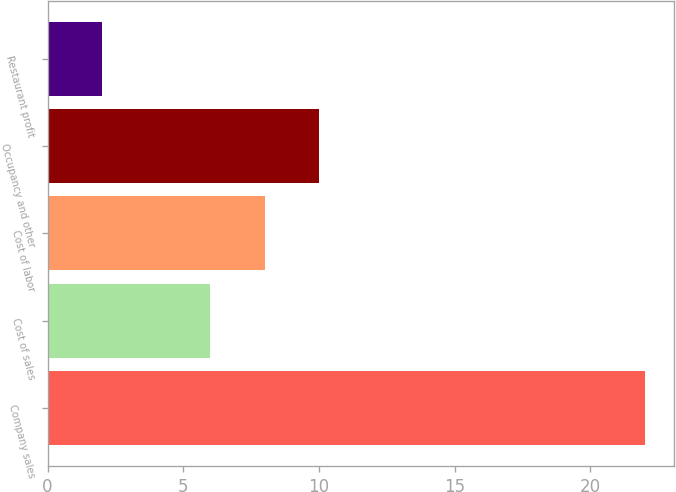Convert chart to OTSL. <chart><loc_0><loc_0><loc_500><loc_500><bar_chart><fcel>Company sales<fcel>Cost of sales<fcel>Cost of labor<fcel>Occupancy and other<fcel>Restaurant profit<nl><fcel>22<fcel>6<fcel>8<fcel>10<fcel>2<nl></chart> 